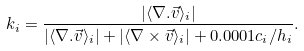<formula> <loc_0><loc_0><loc_500><loc_500>k _ { i } = \frac { | \langle \nabla . \vec { v } \rangle _ { i } | } { | \langle \nabla . \vec { v } \rangle _ { i } | + | \langle \nabla \times \vec { v } \rangle _ { i } | + 0 . 0 0 0 1 c _ { i } / h _ { i } } .</formula> 